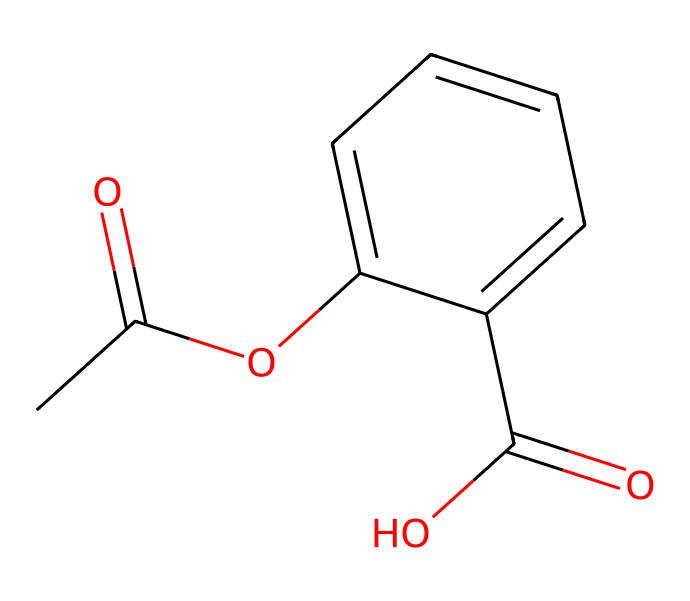what is the molecular formula of this chemical? The molecular formula can be derived by counting the number of each type of atom present in the SMILES representation. From the SMILES, we identify 10 carbons (C), 10 hydrogens (H), 5 oxygens (O), leading to the formula C10H10O5.
Answer: C10H10O5 how many rings are present in this chemical structure? In the chemical structure, we see the presence of one cyclic portion indicated by the occurrence of 'C1' and 'C=C' in the SMILES, which points to the existence of a single ring structure in the compound.
Answer: 1 is this chemical a solid, liquid, or gas at room temperature? Essential oils, which this chemical likely represents due to its structure, are generally liquid at room temperature, which is typical for many organic compounds of this nature.
Answer: liquid what functional groups can be identified in this chemical? By analyzing the SMILES, we can identify various functional groups such as esters (from the 'CC(=O)O' part) and carboxylic acids (the 'C(=O)O' group). Each of these groups contributes specific properties to the chemical.
Answer: ester, carboxylic acid does this chemical have any chiral centers? A chiral center is identified by looking for carbon atoms bonded to four different groups. In this structure, examining the connectivity reveals that there are no such carbon atoms present, indicating no chiral centers.
Answer: no what type of sensory effect is this chemical primarily associated with in aromatherapy? Chemicals derived from this structure typically have calming and soothing properties noted in aromatherapy practices, often promoting relaxation and tranquility.
Answer: calming how does the presence of oxygen atoms affect the aroma of this chemical? The oxygen atoms in this structure, especially involved in functional groups like esters and carboxylic acids, contribute significantly to the aroma by providing various fragrance notes that influence the overall sensory experience.
Answer: enhances aroma 